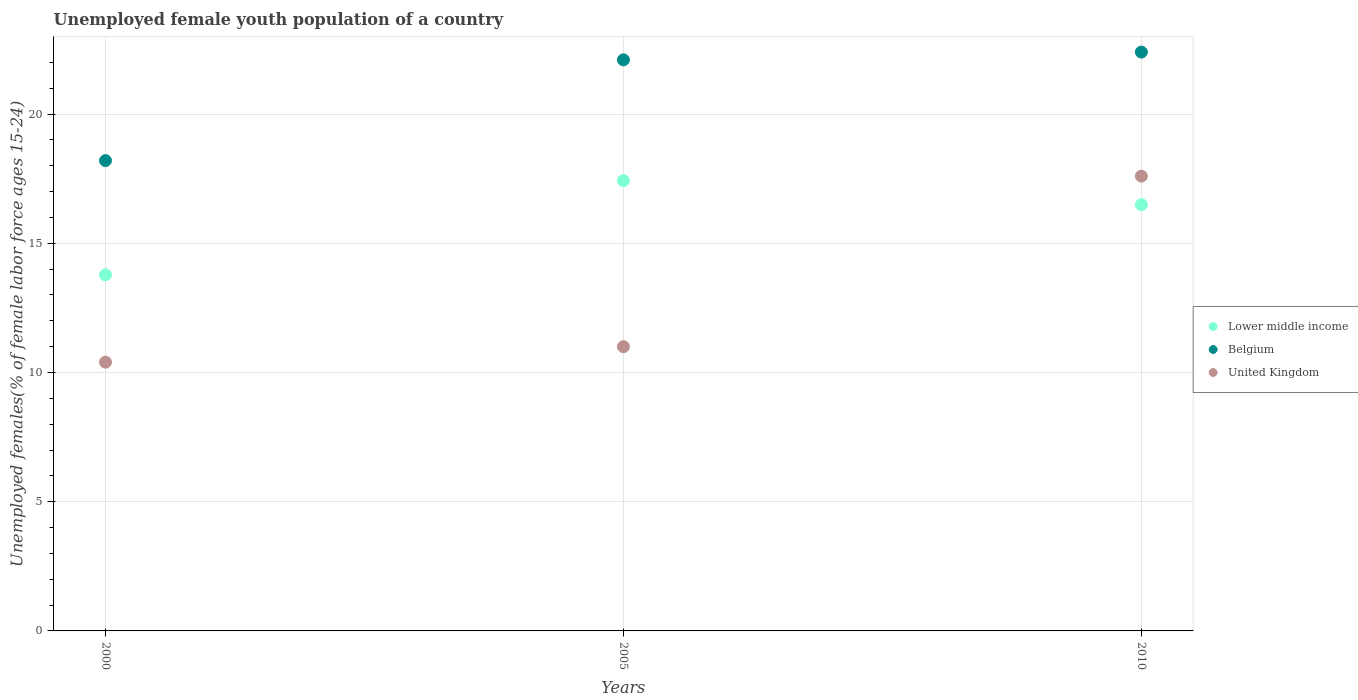How many different coloured dotlines are there?
Your answer should be compact. 3. What is the percentage of unemployed female youth population in United Kingdom in 2000?
Keep it short and to the point. 10.4. Across all years, what is the maximum percentage of unemployed female youth population in Belgium?
Give a very brief answer. 22.4. Across all years, what is the minimum percentage of unemployed female youth population in Lower middle income?
Ensure brevity in your answer.  13.78. What is the difference between the percentage of unemployed female youth population in Belgium in 2005 and that in 2010?
Ensure brevity in your answer.  -0.3. What is the difference between the percentage of unemployed female youth population in Lower middle income in 2005 and the percentage of unemployed female youth population in United Kingdom in 2010?
Provide a succinct answer. -0.18. What is the average percentage of unemployed female youth population in Belgium per year?
Keep it short and to the point. 20.9. In the year 2010, what is the difference between the percentage of unemployed female youth population in Lower middle income and percentage of unemployed female youth population in Belgium?
Your response must be concise. -5.91. What is the ratio of the percentage of unemployed female youth population in United Kingdom in 2000 to that in 2010?
Your response must be concise. 0.59. Is the difference between the percentage of unemployed female youth population in Lower middle income in 2005 and 2010 greater than the difference between the percentage of unemployed female youth population in Belgium in 2005 and 2010?
Your response must be concise. Yes. What is the difference between the highest and the second highest percentage of unemployed female youth population in Lower middle income?
Your answer should be compact. 0.93. What is the difference between the highest and the lowest percentage of unemployed female youth population in Lower middle income?
Make the answer very short. 3.64. In how many years, is the percentage of unemployed female youth population in Belgium greater than the average percentage of unemployed female youth population in Belgium taken over all years?
Ensure brevity in your answer.  2. Is the sum of the percentage of unemployed female youth population in United Kingdom in 2000 and 2005 greater than the maximum percentage of unemployed female youth population in Belgium across all years?
Offer a terse response. No. Does the percentage of unemployed female youth population in United Kingdom monotonically increase over the years?
Your answer should be compact. Yes. Is the percentage of unemployed female youth population in Belgium strictly greater than the percentage of unemployed female youth population in United Kingdom over the years?
Provide a short and direct response. Yes. Is the percentage of unemployed female youth population in Belgium strictly less than the percentage of unemployed female youth population in United Kingdom over the years?
Provide a short and direct response. No. Are the values on the major ticks of Y-axis written in scientific E-notation?
Keep it short and to the point. No. What is the title of the graph?
Provide a short and direct response. Unemployed female youth population of a country. Does "Burundi" appear as one of the legend labels in the graph?
Your answer should be compact. No. What is the label or title of the X-axis?
Offer a terse response. Years. What is the label or title of the Y-axis?
Provide a short and direct response. Unemployed females(% of female labor force ages 15-24). What is the Unemployed females(% of female labor force ages 15-24) of Lower middle income in 2000?
Your response must be concise. 13.78. What is the Unemployed females(% of female labor force ages 15-24) in Belgium in 2000?
Ensure brevity in your answer.  18.2. What is the Unemployed females(% of female labor force ages 15-24) in United Kingdom in 2000?
Make the answer very short. 10.4. What is the Unemployed females(% of female labor force ages 15-24) of Lower middle income in 2005?
Your response must be concise. 17.42. What is the Unemployed females(% of female labor force ages 15-24) of Belgium in 2005?
Your answer should be very brief. 22.1. What is the Unemployed females(% of female labor force ages 15-24) of United Kingdom in 2005?
Offer a terse response. 11. What is the Unemployed females(% of female labor force ages 15-24) in Lower middle income in 2010?
Provide a succinct answer. 16.49. What is the Unemployed females(% of female labor force ages 15-24) of Belgium in 2010?
Provide a short and direct response. 22.4. What is the Unemployed females(% of female labor force ages 15-24) in United Kingdom in 2010?
Offer a very short reply. 17.6. Across all years, what is the maximum Unemployed females(% of female labor force ages 15-24) of Lower middle income?
Your answer should be compact. 17.42. Across all years, what is the maximum Unemployed females(% of female labor force ages 15-24) in Belgium?
Offer a terse response. 22.4. Across all years, what is the maximum Unemployed females(% of female labor force ages 15-24) of United Kingdom?
Your response must be concise. 17.6. Across all years, what is the minimum Unemployed females(% of female labor force ages 15-24) of Lower middle income?
Keep it short and to the point. 13.78. Across all years, what is the minimum Unemployed females(% of female labor force ages 15-24) in Belgium?
Your response must be concise. 18.2. Across all years, what is the minimum Unemployed females(% of female labor force ages 15-24) in United Kingdom?
Ensure brevity in your answer.  10.4. What is the total Unemployed females(% of female labor force ages 15-24) in Lower middle income in the graph?
Keep it short and to the point. 47.7. What is the total Unemployed females(% of female labor force ages 15-24) of Belgium in the graph?
Ensure brevity in your answer.  62.7. What is the difference between the Unemployed females(% of female labor force ages 15-24) of Lower middle income in 2000 and that in 2005?
Provide a short and direct response. -3.64. What is the difference between the Unemployed females(% of female labor force ages 15-24) of United Kingdom in 2000 and that in 2005?
Give a very brief answer. -0.6. What is the difference between the Unemployed females(% of female labor force ages 15-24) in Lower middle income in 2000 and that in 2010?
Provide a succinct answer. -2.71. What is the difference between the Unemployed females(% of female labor force ages 15-24) in Lower middle income in 2005 and that in 2010?
Give a very brief answer. 0.93. What is the difference between the Unemployed females(% of female labor force ages 15-24) of United Kingdom in 2005 and that in 2010?
Keep it short and to the point. -6.6. What is the difference between the Unemployed females(% of female labor force ages 15-24) in Lower middle income in 2000 and the Unemployed females(% of female labor force ages 15-24) in Belgium in 2005?
Give a very brief answer. -8.32. What is the difference between the Unemployed females(% of female labor force ages 15-24) of Lower middle income in 2000 and the Unemployed females(% of female labor force ages 15-24) of United Kingdom in 2005?
Keep it short and to the point. 2.78. What is the difference between the Unemployed females(% of female labor force ages 15-24) of Lower middle income in 2000 and the Unemployed females(% of female labor force ages 15-24) of Belgium in 2010?
Your answer should be very brief. -8.62. What is the difference between the Unemployed females(% of female labor force ages 15-24) of Lower middle income in 2000 and the Unemployed females(% of female labor force ages 15-24) of United Kingdom in 2010?
Offer a terse response. -3.82. What is the difference between the Unemployed females(% of female labor force ages 15-24) of Belgium in 2000 and the Unemployed females(% of female labor force ages 15-24) of United Kingdom in 2010?
Offer a terse response. 0.6. What is the difference between the Unemployed females(% of female labor force ages 15-24) in Lower middle income in 2005 and the Unemployed females(% of female labor force ages 15-24) in Belgium in 2010?
Your answer should be compact. -4.98. What is the difference between the Unemployed females(% of female labor force ages 15-24) in Lower middle income in 2005 and the Unemployed females(% of female labor force ages 15-24) in United Kingdom in 2010?
Your answer should be compact. -0.18. What is the difference between the Unemployed females(% of female labor force ages 15-24) in Belgium in 2005 and the Unemployed females(% of female labor force ages 15-24) in United Kingdom in 2010?
Make the answer very short. 4.5. What is the average Unemployed females(% of female labor force ages 15-24) of Lower middle income per year?
Ensure brevity in your answer.  15.9. What is the average Unemployed females(% of female labor force ages 15-24) in Belgium per year?
Make the answer very short. 20.9. In the year 2000, what is the difference between the Unemployed females(% of female labor force ages 15-24) in Lower middle income and Unemployed females(% of female labor force ages 15-24) in Belgium?
Offer a terse response. -4.42. In the year 2000, what is the difference between the Unemployed females(% of female labor force ages 15-24) in Lower middle income and Unemployed females(% of female labor force ages 15-24) in United Kingdom?
Your answer should be very brief. 3.38. In the year 2005, what is the difference between the Unemployed females(% of female labor force ages 15-24) in Lower middle income and Unemployed females(% of female labor force ages 15-24) in Belgium?
Offer a very short reply. -4.68. In the year 2005, what is the difference between the Unemployed females(% of female labor force ages 15-24) of Lower middle income and Unemployed females(% of female labor force ages 15-24) of United Kingdom?
Provide a short and direct response. 6.42. In the year 2005, what is the difference between the Unemployed females(% of female labor force ages 15-24) in Belgium and Unemployed females(% of female labor force ages 15-24) in United Kingdom?
Offer a very short reply. 11.1. In the year 2010, what is the difference between the Unemployed females(% of female labor force ages 15-24) in Lower middle income and Unemployed females(% of female labor force ages 15-24) in Belgium?
Offer a terse response. -5.91. In the year 2010, what is the difference between the Unemployed females(% of female labor force ages 15-24) in Lower middle income and Unemployed females(% of female labor force ages 15-24) in United Kingdom?
Your answer should be very brief. -1.1. In the year 2010, what is the difference between the Unemployed females(% of female labor force ages 15-24) in Belgium and Unemployed females(% of female labor force ages 15-24) in United Kingdom?
Your answer should be compact. 4.8. What is the ratio of the Unemployed females(% of female labor force ages 15-24) in Lower middle income in 2000 to that in 2005?
Your response must be concise. 0.79. What is the ratio of the Unemployed females(% of female labor force ages 15-24) of Belgium in 2000 to that in 2005?
Provide a short and direct response. 0.82. What is the ratio of the Unemployed females(% of female labor force ages 15-24) of United Kingdom in 2000 to that in 2005?
Offer a very short reply. 0.95. What is the ratio of the Unemployed females(% of female labor force ages 15-24) in Lower middle income in 2000 to that in 2010?
Provide a short and direct response. 0.84. What is the ratio of the Unemployed females(% of female labor force ages 15-24) of Belgium in 2000 to that in 2010?
Offer a terse response. 0.81. What is the ratio of the Unemployed females(% of female labor force ages 15-24) of United Kingdom in 2000 to that in 2010?
Provide a short and direct response. 0.59. What is the ratio of the Unemployed females(% of female labor force ages 15-24) of Lower middle income in 2005 to that in 2010?
Ensure brevity in your answer.  1.06. What is the ratio of the Unemployed females(% of female labor force ages 15-24) of Belgium in 2005 to that in 2010?
Offer a very short reply. 0.99. What is the ratio of the Unemployed females(% of female labor force ages 15-24) in United Kingdom in 2005 to that in 2010?
Ensure brevity in your answer.  0.62. What is the difference between the highest and the second highest Unemployed females(% of female labor force ages 15-24) in Lower middle income?
Your response must be concise. 0.93. What is the difference between the highest and the second highest Unemployed females(% of female labor force ages 15-24) of Belgium?
Keep it short and to the point. 0.3. What is the difference between the highest and the lowest Unemployed females(% of female labor force ages 15-24) in Lower middle income?
Make the answer very short. 3.64. What is the difference between the highest and the lowest Unemployed females(% of female labor force ages 15-24) in Belgium?
Give a very brief answer. 4.2. 